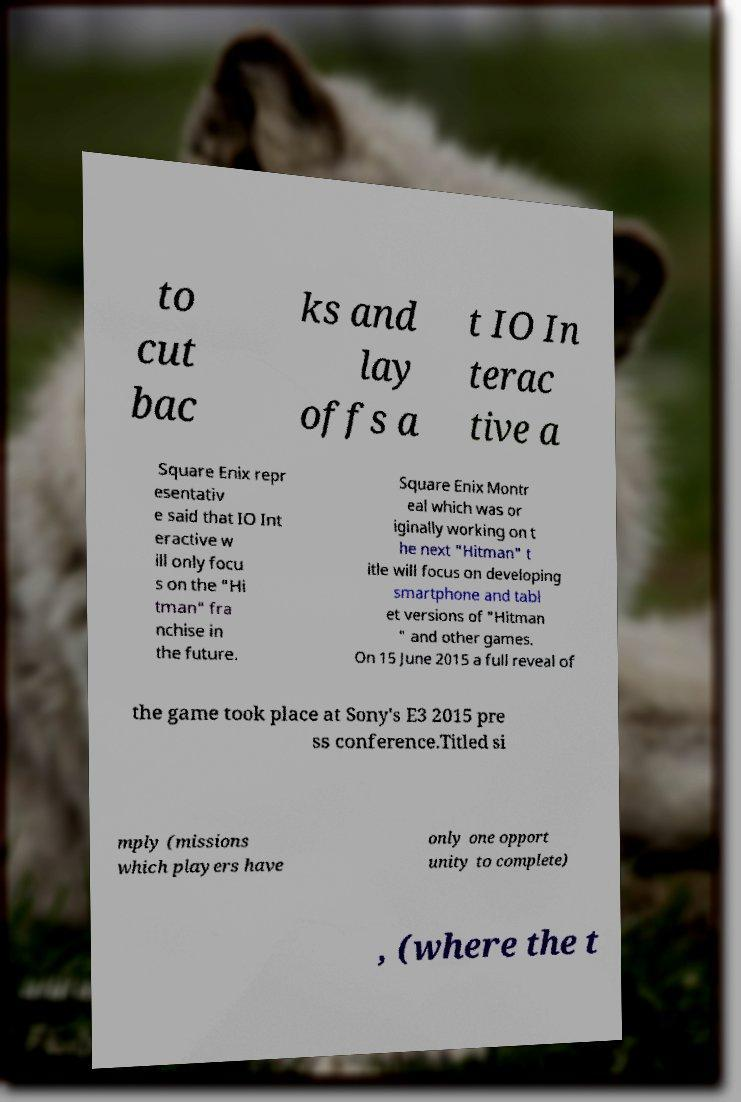Can you read and provide the text displayed in the image?This photo seems to have some interesting text. Can you extract and type it out for me? to cut bac ks and lay offs a t IO In terac tive a Square Enix repr esentativ e said that IO Int eractive w ill only focu s on the "Hi tman" fra nchise in the future. Square Enix Montr eal which was or iginally working on t he next "Hitman" t itle will focus on developing smartphone and tabl et versions of "Hitman " and other games. On 15 June 2015 a full reveal of the game took place at Sony's E3 2015 pre ss conference.Titled si mply (missions which players have only one opport unity to complete) , (where the t 